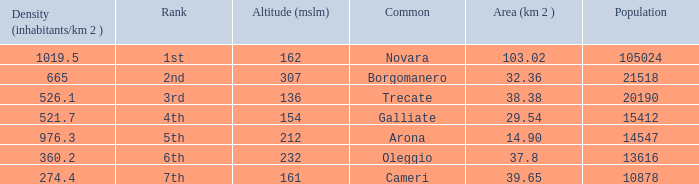Where does the common of Galliate rank in population? 4th. 